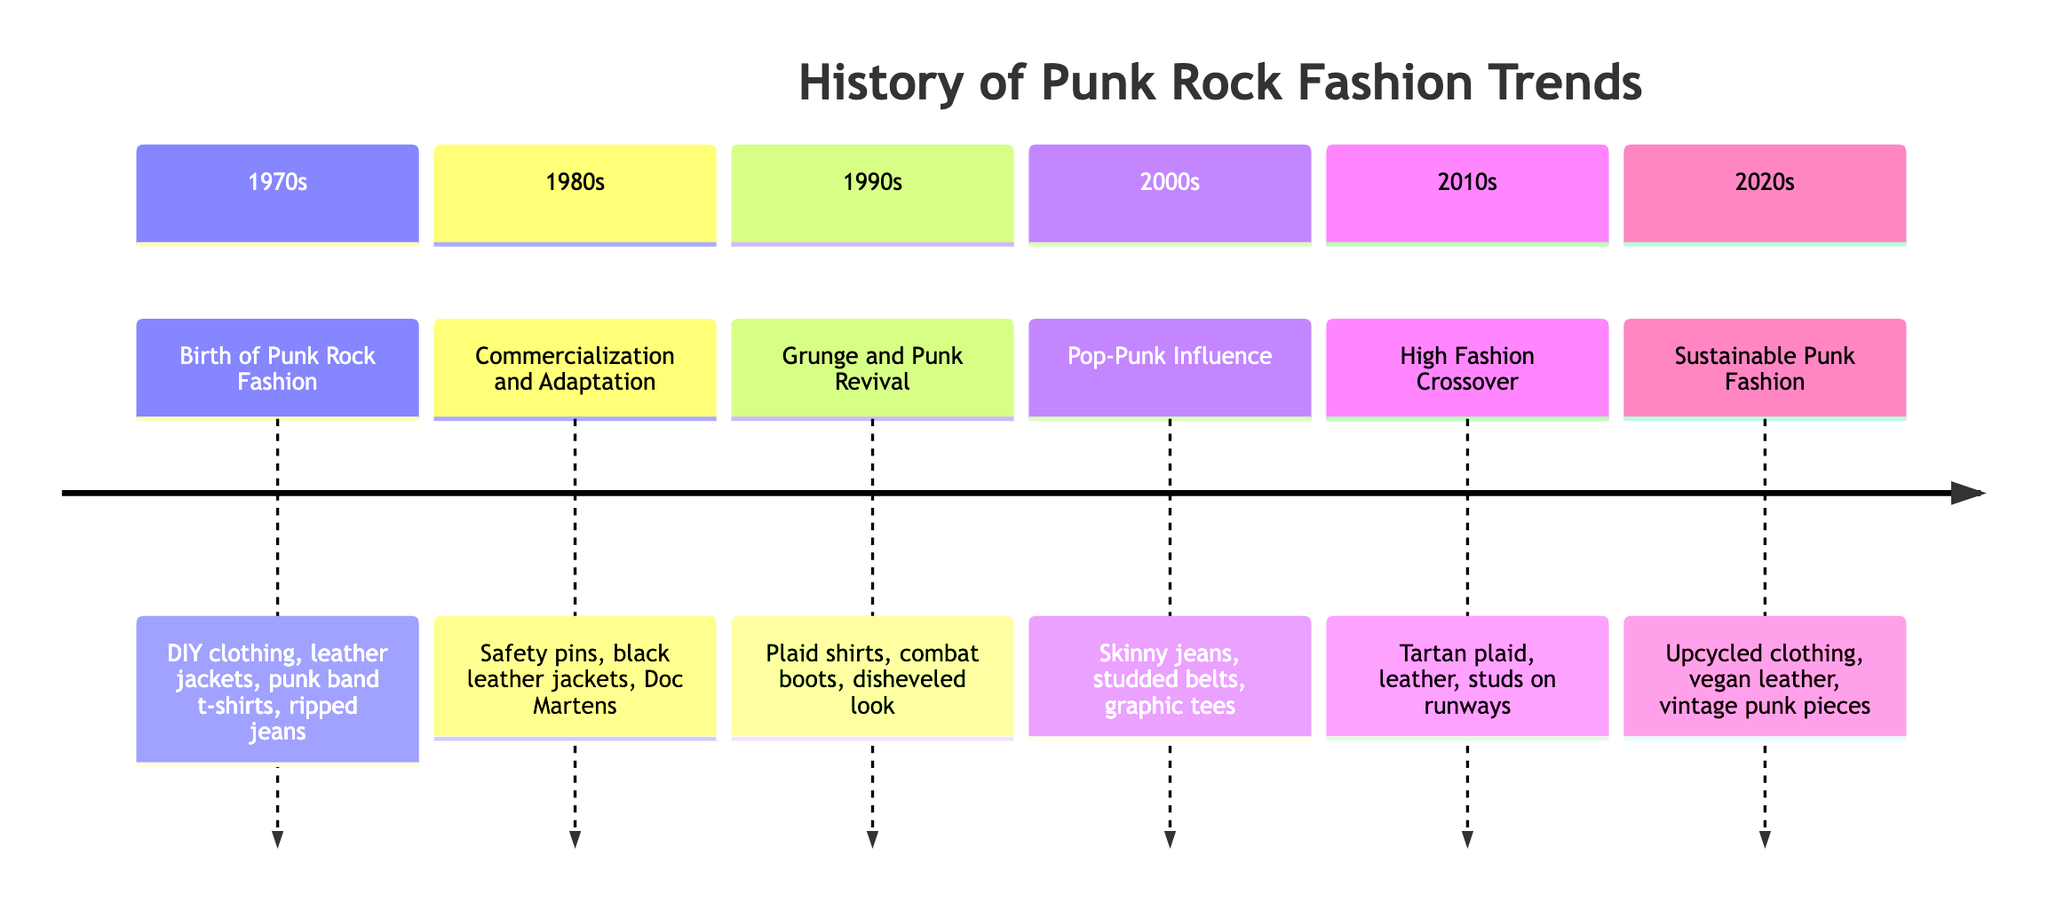What decade marks the birth of punk rock fashion? The diagram indicates the 1970s as the decade that marks the birth of punk rock fashion, detailing its emergence in the UK and New York with specific characteristics.
Answer: 1970s Which accessory was adopted by Vivienne Westwood in the 1980s? According to the timeline, the safety pin was an essential punk accessory that was adopted by designer Vivienne Westwood in the 1980s, indicating its transition into mainstream fashion.
Answer: Safety pin What type of clothing became popular in the 1990s? The diagram specifies that plaid shirts and combat boots became popular during the 1990s, along with a disheveled look influenced by grunge fashion, which also revived punk elements.
Answer: Plaid shirts In which decade did skinny jeans gain popularity? The timeline notes that skinny jeans rose to popularity in the 2000s due to the influence of pop-punk bands, showcasing a change in punk fashion style towards a more polished look.
Answer: 2000s What was a significant fashion trend in the 2010s? The diagram indicates that tartan plaid, leather, and studs featured prominently on runways during the 2010s, marking a high fashion crossover with punk influence demonstrated by certain designers.
Answer: Tartan plaid How did punk fashion reflect sustainability in the 2020s? The timeline illustrates that in the 2020s, sustainable punk fashion featured practices like upcycled clothing and vegan leather that align with punk's anti-establishment ethos, showcasing a modern adaptation to the original values of punk.
Answer: Upcycled clothing Which bands influenced the initial punk fashion of the 1970s? The diagram mentions that The Ramones and Sex Pistols were key influencers of the punk rock fashion that emerged in the 1970s, identifying notable figures in the movement.
Answer: The Ramones and Sex Pistols What fashion elements were common in mainstream collections during the 2010s? It is stated in the timeline that elements like tartan plaid, leather, and studs became common features in the high fashion collections during the 2010s, highlighting the crossover between punk and mainstream fashion.
Answer: Tartan plaid, leather, and studs What trend characterized the 2020s punk fashion movement? The timeline notes that the punk fashion movement in the 2020s was characterized by sustainable practices such as the rise of vintage punk pieces, reflecting a trend towards environmental consciousness within the fashion industry.
Answer: Sustainable practices 